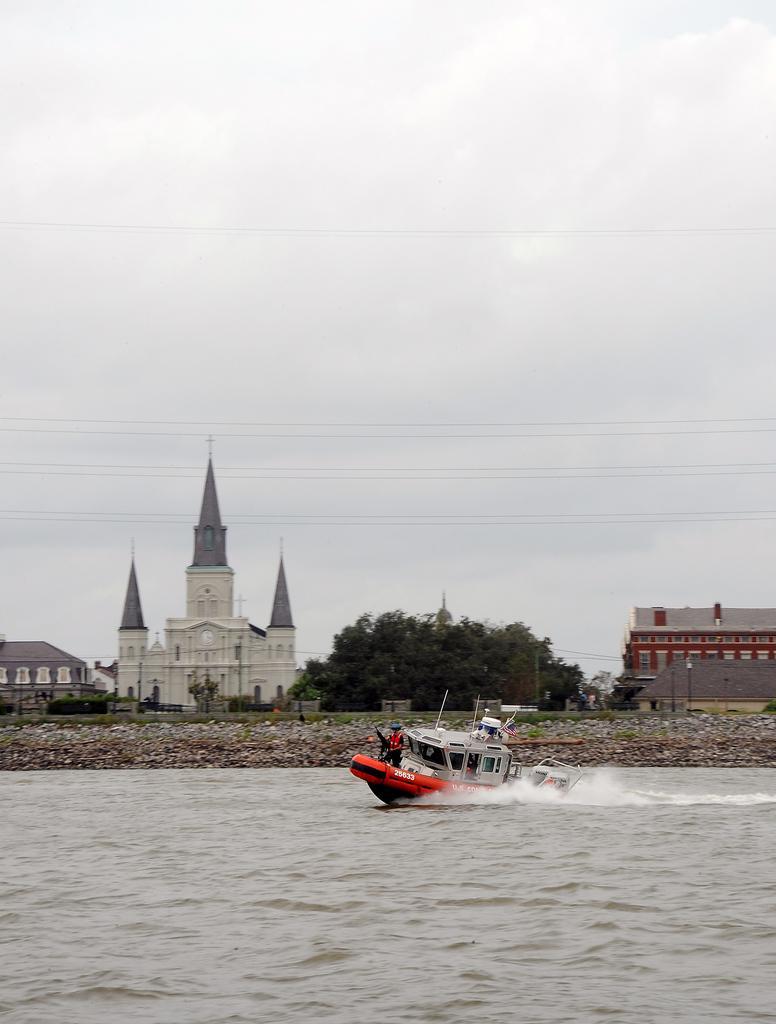How would you summarize this image in a sentence or two? In this image I can see the boat on the water. There is a person standing in the boat. In the background I can see the rocks, buildings and many trees. In the background I can see the sky. 